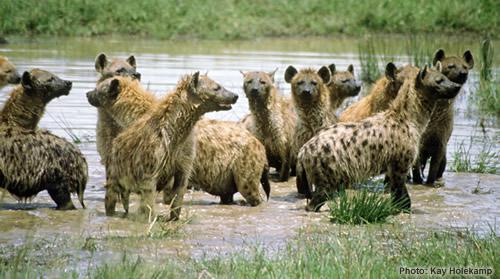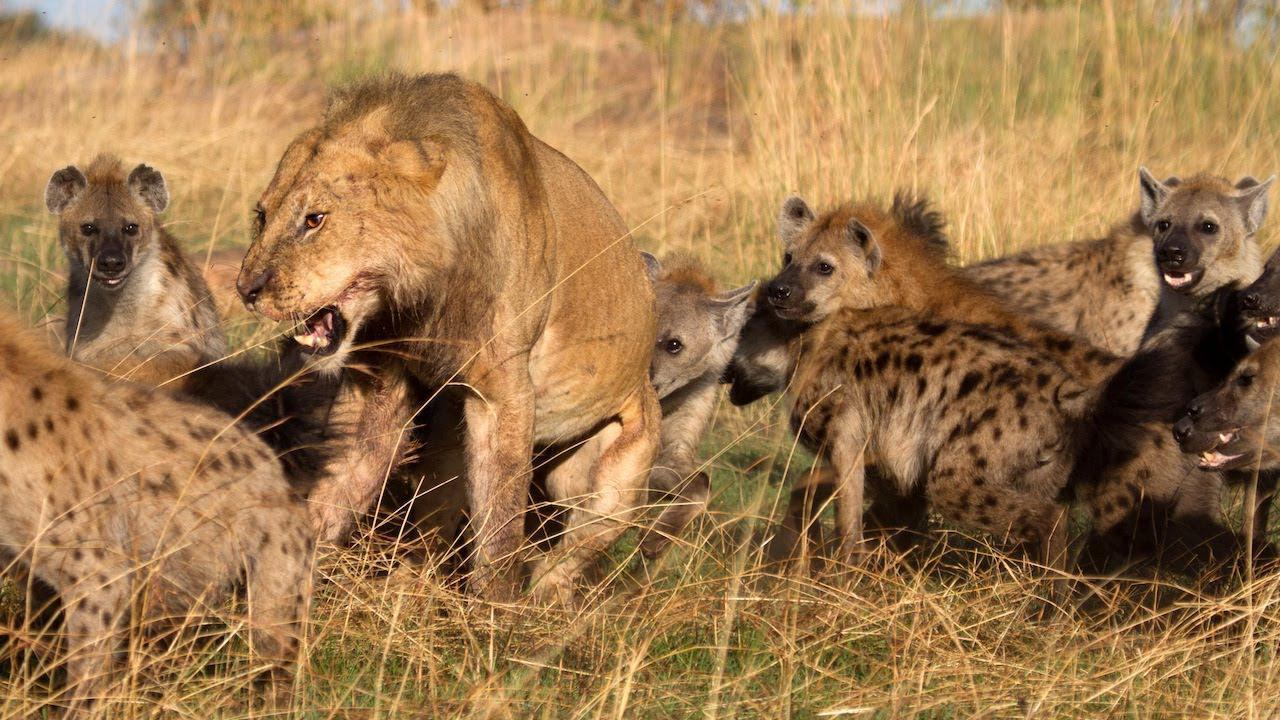The first image is the image on the left, the second image is the image on the right. Evaluate the accuracy of this statement regarding the images: "A lion is with a group of hyenas in at least one of the images.". Is it true? Answer yes or no. Yes. The first image is the image on the left, the second image is the image on the right. Evaluate the accuracy of this statement regarding the images: "One image contains at least one lion.". Is it true? Answer yes or no. Yes. 